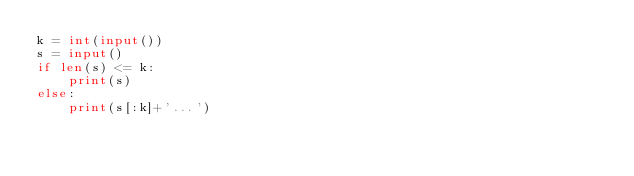<code> <loc_0><loc_0><loc_500><loc_500><_Python_>k = int(input())
s = input()
if len(s) <= k:
    print(s)
else:
    print(s[:k]+'...')</code> 